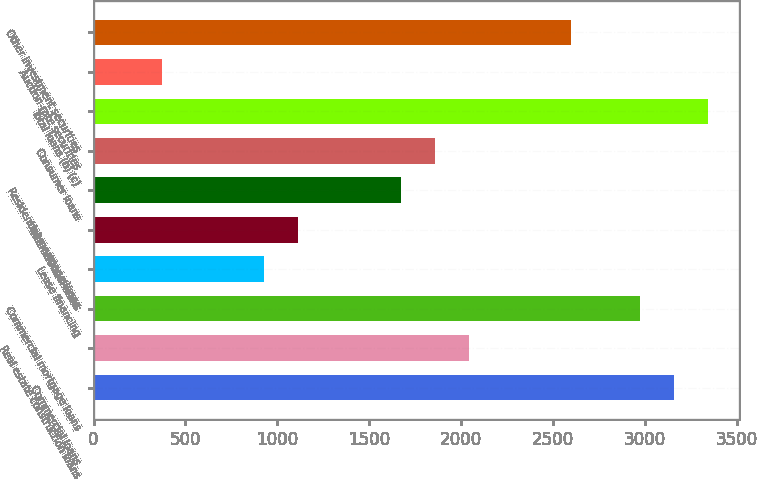Convert chart to OTSL. <chart><loc_0><loc_0><loc_500><loc_500><bar_chart><fcel>Commercial loans<fcel>Real estate construction loans<fcel>Commercial mortgage loans<fcel>Lease financing<fcel>International loans<fcel>Residential mortgage loans<fcel>Consumer loans<fcel>Total loans (b) (c)<fcel>Auction-rate securities<fcel>Other investment securities<nl><fcel>3157.9<fcel>2043.7<fcel>2972.2<fcel>929.5<fcel>1115.2<fcel>1672.3<fcel>1858<fcel>3343.6<fcel>372.4<fcel>2600.8<nl></chart> 